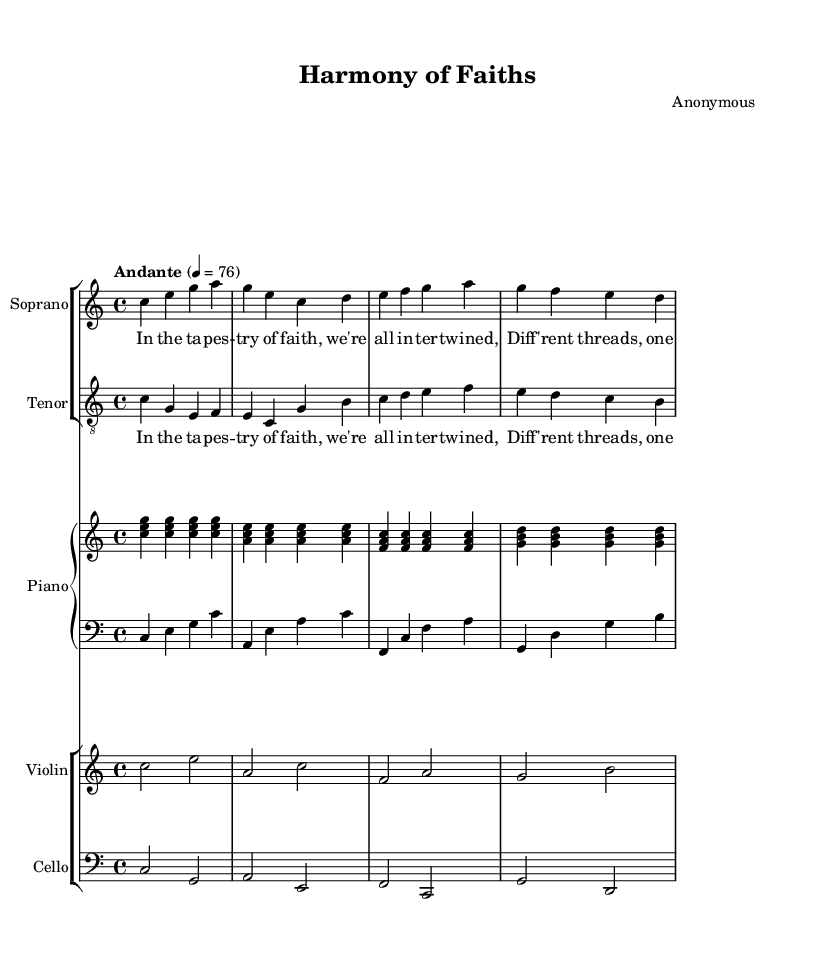What is the key signature of this music? The key signature is indicated at the beginning of the score and shows that there are no sharps or flats present. This identifies the piece as being in C major.
Answer: C major What is the time signature of this music? The time signature is located at the beginning of the score, indicating the rhythm pattern of the music. It shows that there are four beats per measure, which is represented as 4/4.
Answer: 4/4 What is the tempo of this music? The tempo is specified at the beginning of the sheet music, indicating the speed at which the piece should be played. It is marked as "Andante" with a metronome marking of 76 beats per minute.
Answer: Andante 4 = 76 How many voices are present in the score? The score contains two distinct vocal parts, a Soprano and a Tenor, each represented on separate staves in the music sheet.
Answer: Two Which instruments are included in the piano staff? The piano staff is separated into two parts, with one for the right hand and one for the left hand, indicating that both hands will play separate melodies simultaneously.
Answer: Right Hand and Left Hand What do the lyrics of the piece convey? The lyrics present the themes of interconnectedness and tolerance among different faiths. To understand the content, one must analyze the words specified as poetic phrases that express unity despite diversity.
Answer: Unity in diversity How does the structure support interfaith dialogue? The combination of vocal lines and instrumental accompaniment creates a dialogue-like interaction that symbolizes communication among different faiths, represented musically through harmonizing and contrasting melodies.
Answer: Musical dialogue 